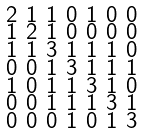Convert formula to latex. <formula><loc_0><loc_0><loc_500><loc_500>\begin{smallmatrix} 2 & 1 & 1 & 0 & 1 & 0 & 0 \\ 1 & 2 & 1 & 0 & 0 & 0 & 0 \\ 1 & 1 & 3 & 1 & 1 & 1 & 0 \\ 0 & 0 & 1 & 3 & 1 & 1 & 1 \\ 1 & 0 & 1 & 1 & 3 & 1 & 0 \\ 0 & 0 & 1 & 1 & 1 & 3 & 1 \\ 0 & 0 & 0 & 1 & 0 & 1 & 3 \end{smallmatrix}</formula> 